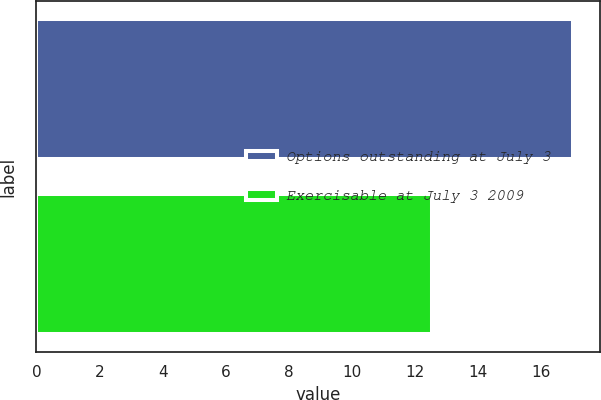<chart> <loc_0><loc_0><loc_500><loc_500><bar_chart><fcel>Options outstanding at July 3<fcel>Exercisable at July 3 2009<nl><fcel>17<fcel>12.53<nl></chart> 